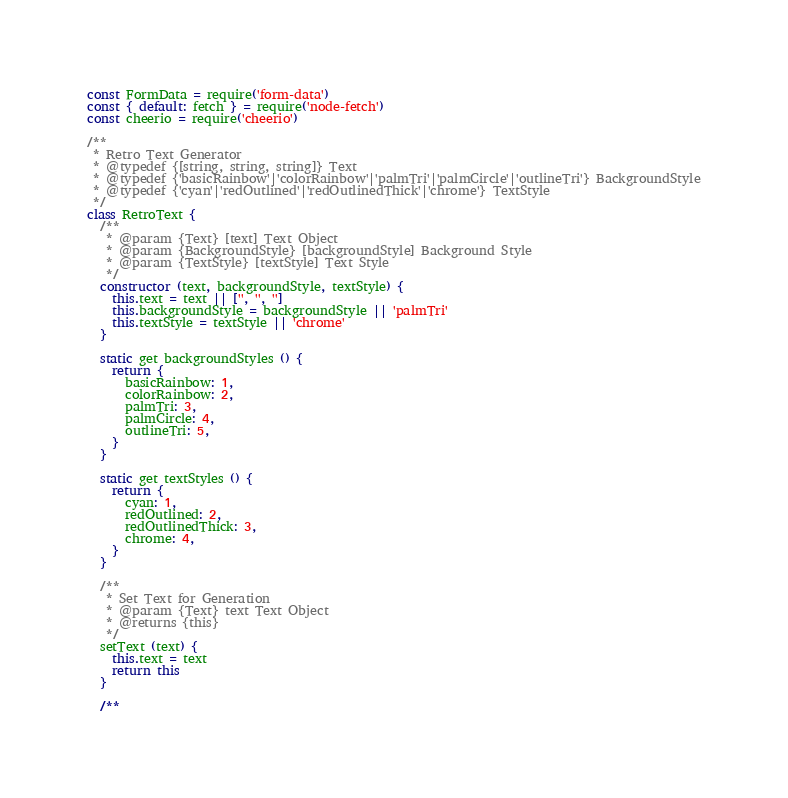<code> <loc_0><loc_0><loc_500><loc_500><_JavaScript_>const FormData = require('form-data')
const { default: fetch } = require('node-fetch')
const cheerio = require('cheerio')

/**
 * Retro Text Generator
 * @typedef {[string, string, string]} Text
 * @typedef {'basicRainbow'|'colorRainbow'|'palmTri'|'palmCircle'|'outlineTri'} BackgroundStyle
 * @typedef {'cyan'|'redOutlined'|'redOutlinedThick'|'chrome'} TextStyle
 */
class RetroText {
  /**
   * @param {Text} [text] Text Object
   * @param {BackgroundStyle} [backgroundStyle] Background Style
   * @param {TextStyle} [textStyle] Text Style
   */
  constructor (text, backgroundStyle, textStyle) {
    this.text = text || ['', '', '']
    this.backgroundStyle = backgroundStyle || 'palmTri'
    this.textStyle = textStyle || 'chrome'
  }

  static get backgroundStyles () {
    return {
      basicRainbow: 1,
      colorRainbow: 2,
      palmTri: 3,
      palmCircle: 4,
      outlineTri: 5,
    }
  }

  static get textStyles () {
    return {
      cyan: 1,
      redOutlined: 2,
      redOutlinedThick: 3,
      chrome: 4,
    }
  }

  /**
   * Set Text for Generation
   * @param {Text} text Text Object
   * @returns {this}
   */
  setText (text) {
    this.text = text
    return this
  }

  /**</code> 